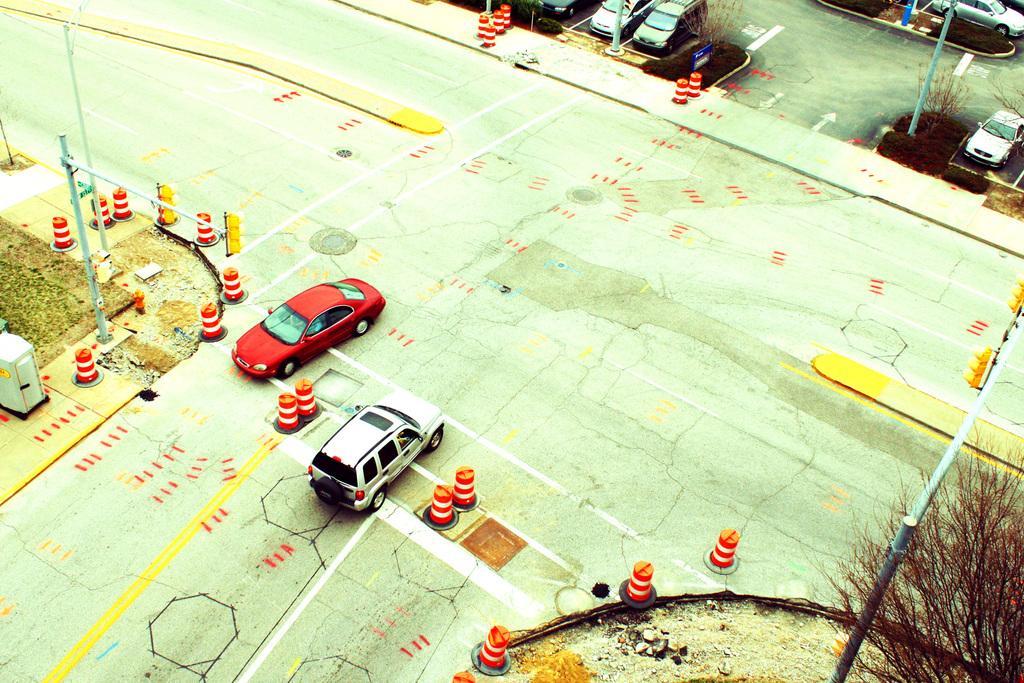How would you summarize this image in a sentence or two? In this picture I can see the road on which there are 2 cars and number of orange color things and I can see few poles and a tree on the right bottom corner of this picture. In the background I can see the parking lot on which there are few cars, plants and 2 poles. 